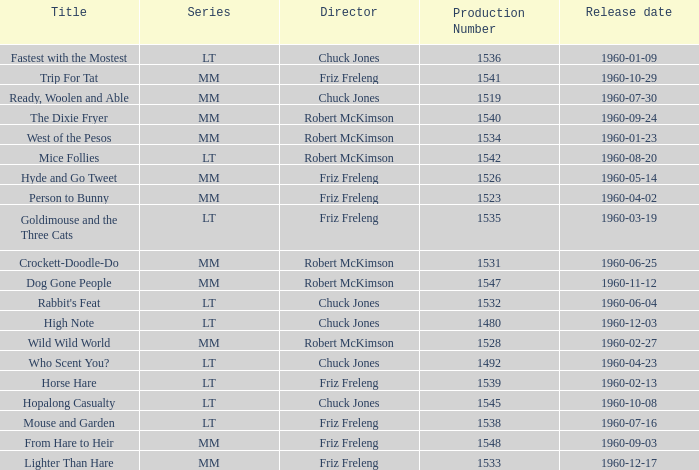What is the Series number of the episode with a production number of 1547? MM. 